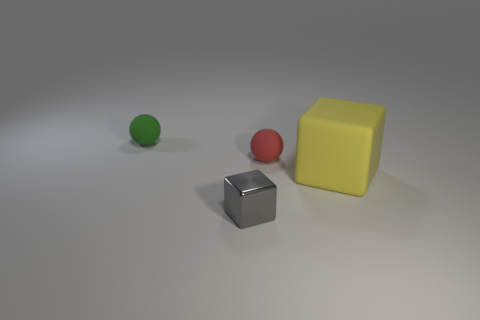Is there any other thing that has the same material as the tiny gray block?
Provide a succinct answer. No. What number of other things are the same size as the yellow cube?
Your answer should be compact. 0. What is the size of the rubber sphere that is on the left side of the gray metallic block?
Your answer should be very brief. Small. What number of small brown balls are the same material as the green ball?
Your answer should be compact. 0. Does the small rubber object that is to the right of the tiny green thing have the same shape as the yellow object?
Your response must be concise. No. What shape is the tiny matte thing on the right side of the small gray cube?
Keep it short and to the point. Sphere. What is the tiny green object made of?
Provide a succinct answer. Rubber. What is the color of the rubber object that is the same size as the green matte ball?
Offer a very short reply. Red. Is the tiny gray thing the same shape as the tiny green matte thing?
Ensure brevity in your answer.  No. What material is the object that is both in front of the red rubber sphere and to the left of the red thing?
Give a very brief answer. Metal. 